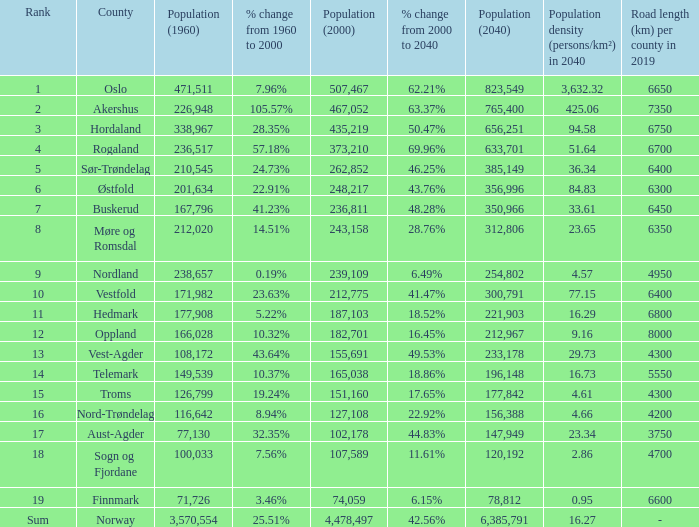What was the population of a county in 2040 that had a population less than 108,172 in 2000 and less than 107,589 in 1960? 2.0. 